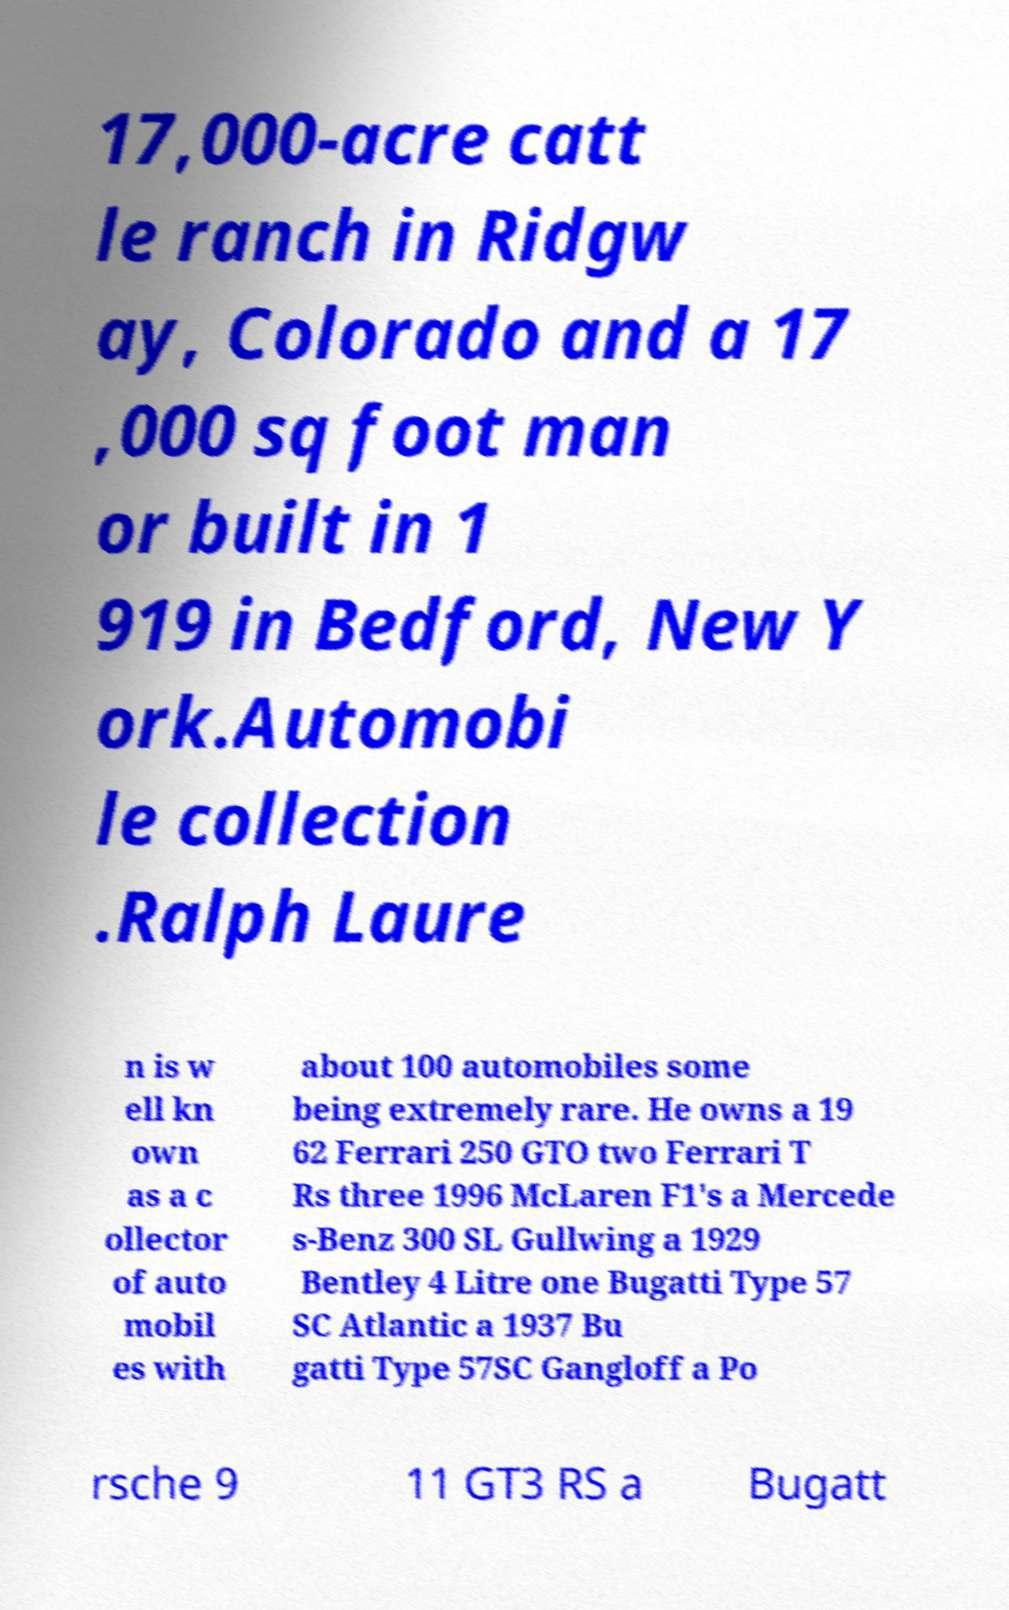Please read and relay the text visible in this image. What does it say? 17,000-acre catt le ranch in Ridgw ay, Colorado and a 17 ,000 sq foot man or built in 1 919 in Bedford, New Y ork.Automobi le collection .Ralph Laure n is w ell kn own as a c ollector of auto mobil es with about 100 automobiles some being extremely rare. He owns a 19 62 Ferrari 250 GTO two Ferrari T Rs three 1996 McLaren F1's a Mercede s-Benz 300 SL Gullwing a 1929 Bentley 4 Litre one Bugatti Type 57 SC Atlantic a 1937 Bu gatti Type 57SC Gangloff a Po rsche 9 11 GT3 RS a Bugatt 